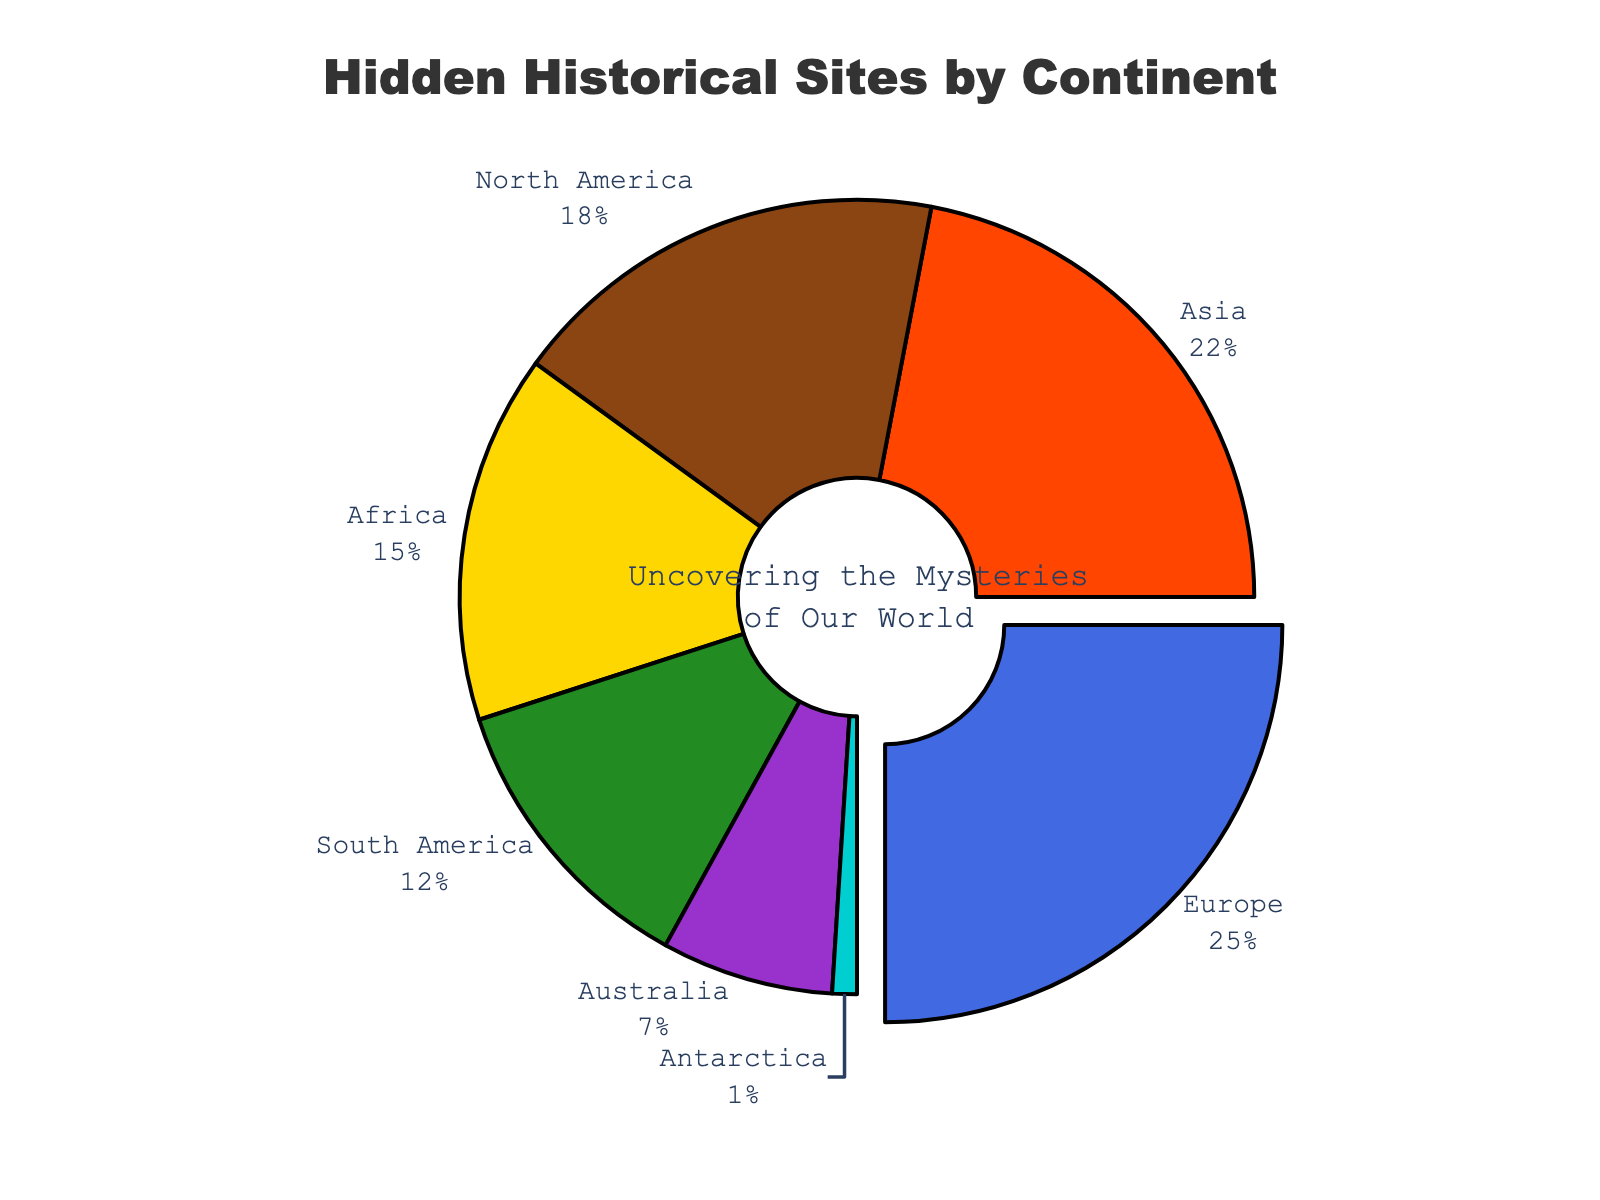Which continent has the highest proportion of hidden historical sites? Europe has the highest proportion of hidden historical sites. The pie chart highlights the largest section with a pull-out effect, indicating it as Europe.
Answer: Europe Which continent has the lowest proportion of hidden historical sites? The smallest proportion is visually represented by the smallest slice of the pie, which corresponds to Antarctica.
Answer: Antarctica What is the combined proportion of hidden historical sites in both Asia and Africa? To find the combined proportion, add the proportions of Asia and Africa. Asia is 0.22, and Africa is 0.15. So, 0.22 + 0.15 = 0.37.
Answer: 0.37 How does the proportion of hidden historical sites in North America compare to that in South America? Comparing the slices of the pie chart, North America's slice is larger than South America's. North America has a proportion of 0.18, while South America has 0.12, which means North America's proportion is higher.
Answer: North America has a higher proportion Which continents together make up over 50% of the hidden historical sites? By adding the proportions, Europe (0.25), plus Asia (0.22), equals 0.47, which is already close to 50%. Adding North America (0.18) exceeds the 50% mark. Therefore, Europe, Asia, and North America together make up more than 50%.
Answer: Europe, Asia, North America What is the visual difference in size between the slice for Europe and the slice for Antarctica? The largest slice, representing Europe, is visually many times larger than the smallest slice, which represents Antarctica. Europe has 25% of the pie, while Antarctica has just 1%. So, Europe’s slice is 25 times the size of Antarctica’s slice.
Answer: Europe’s slice is 25 times larger How does the proportion of hidden historical sites in Africa compare visually to that in Australia? Africa's slice, which represents 15%, is visually larger than Australia's slice, which represents 7%. This can be clearly seen by the difference in the size of the slices in the pie chart.
Answer: Africa’s proportion is higher What percentage of hidden historical sites are found in the combined continents of South America, Australia, and Antarctica? Add the proportions of South America (0.12), Australia (0.07), and Antarctica (0.01): 0.12 + 0.07 + 0.01 = 0.2, which is 20%.
Answer: 20% Which slice is represented by the color blue? The pie chart section colored in blue corresponds to Europe, indicating 25% of hidden historical sites.
Answer: Europe If you were to remove Europe from the chart, what would be the new highest percentage, and which continent would it belong to? Removing Europe (0.25) leaves Asia with the next highest proportion at 0.22, which would then be the largest remaining slice.
Answer: 22%, Asia 